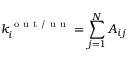<formula> <loc_0><loc_0><loc_500><loc_500>k _ { i } ^ { o u t / u u } = \sum _ { j = 1 } ^ { N } A _ { i j }</formula> 